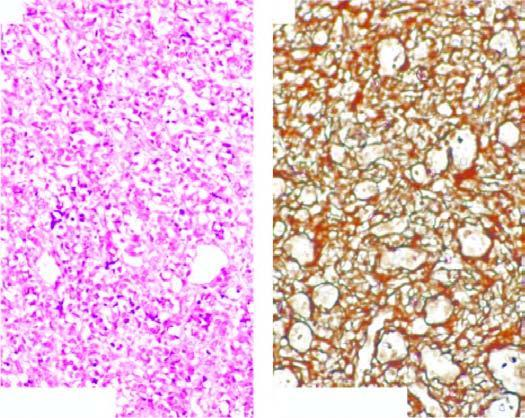re large cystic spaces lined by the flattened endothelial cells and containing lymph line by multiple layers of plump endothelial cells having minimal mitotic activity obliterating the lumina?
Answer the question using a single word or phrase. No 